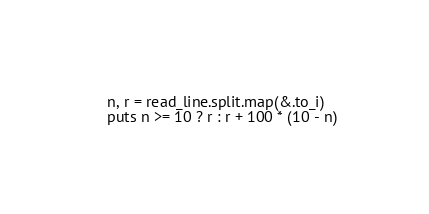<code> <loc_0><loc_0><loc_500><loc_500><_Crystal_>n, r = read_line.split.map(&.to_i)
puts n >= 10 ? r : r + 100 * (10 - n)
</code> 